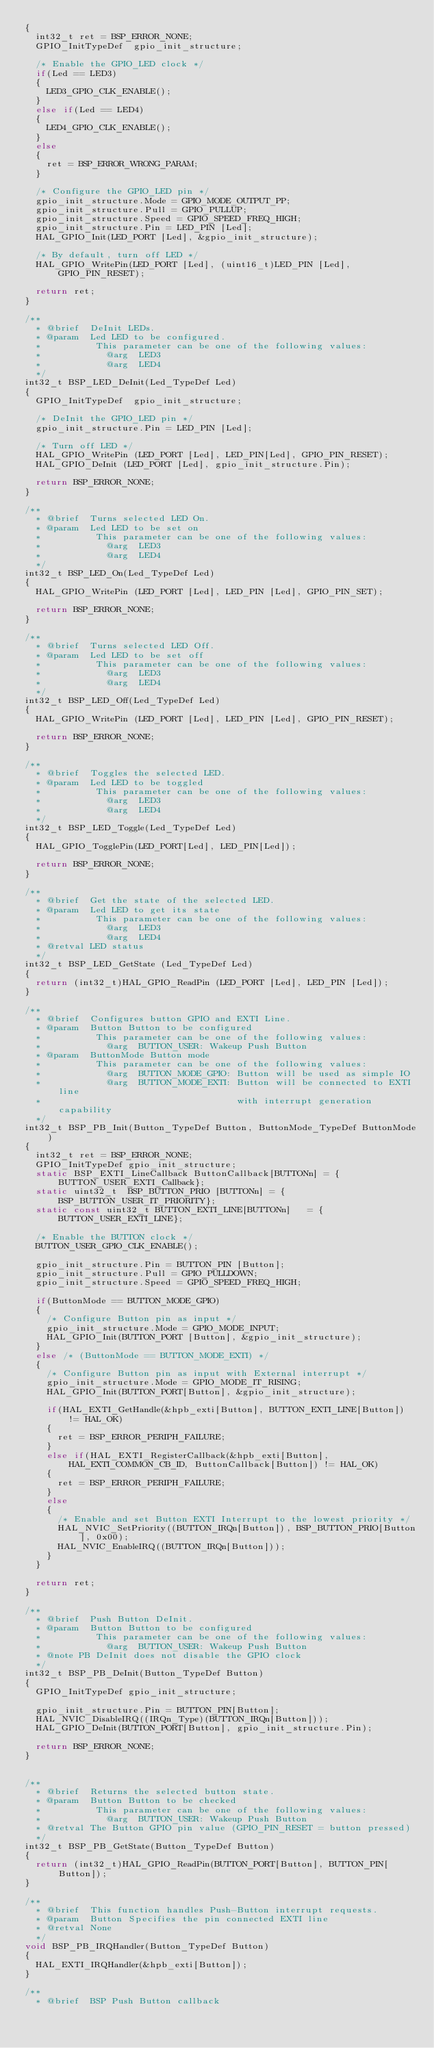Convert code to text. <code><loc_0><loc_0><loc_500><loc_500><_C_>{
  int32_t ret = BSP_ERROR_NONE;
  GPIO_InitTypeDef  gpio_init_structure;

  /* Enable the GPIO_LED clock */
  if(Led == LED3)
  {
    LED3_GPIO_CLK_ENABLE();
  }
  else if(Led == LED4)
  {
    LED4_GPIO_CLK_ENABLE();
  }
  else
  {
    ret = BSP_ERROR_WRONG_PARAM;
  }

  /* Configure the GPIO_LED pin */
  gpio_init_structure.Mode = GPIO_MODE_OUTPUT_PP;
  gpio_init_structure.Pull = GPIO_PULLUP;
  gpio_init_structure.Speed = GPIO_SPEED_FREQ_HIGH;
  gpio_init_structure.Pin = LED_PIN [Led];
  HAL_GPIO_Init(LED_PORT [Led], &gpio_init_structure);

  /* By default, turn off LED */
  HAL_GPIO_WritePin(LED_PORT [Led], (uint16_t)LED_PIN [Led], GPIO_PIN_RESET);

  return ret;
}

/**
  * @brief  DeInit LEDs.
  * @param  Led LED to be configured.
  *          This parameter can be one of the following values:
  *            @arg  LED3
  *            @arg  LED4
  */
int32_t BSP_LED_DeInit(Led_TypeDef Led)
{
  GPIO_InitTypeDef  gpio_init_structure;

  /* DeInit the GPIO_LED pin */
  gpio_init_structure.Pin = LED_PIN [Led];

  /* Turn off LED */
  HAL_GPIO_WritePin (LED_PORT [Led], LED_PIN[Led], GPIO_PIN_RESET);
  HAL_GPIO_DeInit (LED_PORT [Led], gpio_init_structure.Pin);

  return BSP_ERROR_NONE;
}

/**
  * @brief  Turns selected LED On.
  * @param  Led LED to be set on
  *          This parameter can be one of the following values:
  *            @arg  LED3
  *            @arg  LED4
  */
int32_t BSP_LED_On(Led_TypeDef Led)
{
  HAL_GPIO_WritePin (LED_PORT [Led], LED_PIN [Led], GPIO_PIN_SET);

  return BSP_ERROR_NONE;
}

/**
  * @brief  Turns selected LED Off.
  * @param  Led LED to be set off
  *          This parameter can be one of the following values:
  *            @arg  LED3
  *            @arg  LED4
  */
int32_t BSP_LED_Off(Led_TypeDef Led)
{
  HAL_GPIO_WritePin (LED_PORT [Led], LED_PIN [Led], GPIO_PIN_RESET);

  return BSP_ERROR_NONE;
}

/**
  * @brief  Toggles the selected LED.
  * @param  Led LED to be toggled
  *          This parameter can be one of the following values:
  *            @arg  LED3
  *            @arg  LED4
  */
int32_t BSP_LED_Toggle(Led_TypeDef Led)
{
  HAL_GPIO_TogglePin(LED_PORT[Led], LED_PIN[Led]);

  return BSP_ERROR_NONE;
}

/**
  * @brief  Get the state of the selected LED.
  * @param  Led LED to get its state
  *          This parameter can be one of the following values:
  *            @arg  LED3
  *            @arg  LED4
  * @retval LED status
  */
int32_t BSP_LED_GetState (Led_TypeDef Led)
{
  return (int32_t)HAL_GPIO_ReadPin (LED_PORT [Led], LED_PIN [Led]);
}

/**
  * @brief  Configures button GPIO and EXTI Line.
  * @param  Button Button to be configured
  *          This parameter can be one of the following values:
  *            @arg  BUTTON_USER: Wakeup Push Button
  * @param  ButtonMode Button mode
  *          This parameter can be one of the following values:
  *            @arg  BUTTON_MODE_GPIO: Button will be used as simple IO
  *            @arg  BUTTON_MODE_EXTI: Button will be connected to EXTI line
  *                                    with interrupt generation capability
  */
int32_t BSP_PB_Init(Button_TypeDef Button, ButtonMode_TypeDef ButtonMode)
{
  int32_t ret = BSP_ERROR_NONE;
  GPIO_InitTypeDef gpio_init_structure;
  static BSP_EXTI_LineCallback ButtonCallback[BUTTONn] = {BUTTON_USER_EXTI_Callback};
  static uint32_t  BSP_BUTTON_PRIO [BUTTONn] = {BSP_BUTTON_USER_IT_PRIORITY};
  static const uint32_t BUTTON_EXTI_LINE[BUTTONn]   = {BUTTON_USER_EXTI_LINE};

  /* Enable the BUTTON clock */
  BUTTON_USER_GPIO_CLK_ENABLE();

  gpio_init_structure.Pin = BUTTON_PIN [Button];
  gpio_init_structure.Pull = GPIO_PULLDOWN;
  gpio_init_structure.Speed = GPIO_SPEED_FREQ_HIGH;

  if(ButtonMode == BUTTON_MODE_GPIO)
  {
    /* Configure Button pin as input */
    gpio_init_structure.Mode = GPIO_MODE_INPUT;
    HAL_GPIO_Init(BUTTON_PORT [Button], &gpio_init_structure);
  }
  else /* (ButtonMode == BUTTON_MODE_EXTI) */
  {
    /* Configure Button pin as input with External interrupt */
    gpio_init_structure.Mode = GPIO_MODE_IT_RISING;
    HAL_GPIO_Init(BUTTON_PORT[Button], &gpio_init_structure);

    if(HAL_EXTI_GetHandle(&hpb_exti[Button], BUTTON_EXTI_LINE[Button]) != HAL_OK)
    {
      ret = BSP_ERROR_PERIPH_FAILURE;
    }
    else if(HAL_EXTI_RegisterCallback(&hpb_exti[Button],  HAL_EXTI_COMMON_CB_ID, ButtonCallback[Button]) != HAL_OK)
    {
      ret = BSP_ERROR_PERIPH_FAILURE;
    }
    else
    {
      /* Enable and set Button EXTI Interrupt to the lowest priority */
      HAL_NVIC_SetPriority((BUTTON_IRQn[Button]), BSP_BUTTON_PRIO[Button], 0x00);
      HAL_NVIC_EnableIRQ((BUTTON_IRQn[Button]));
    }
  }

  return ret;
}

/**
  * @brief  Push Button DeInit.
  * @param  Button Button to be configured
  *          This parameter can be one of the following values:
  *            @arg  BUTTON_USER: Wakeup Push Button
  * @note PB DeInit does not disable the GPIO clock
  */
int32_t BSP_PB_DeInit(Button_TypeDef Button)
{
  GPIO_InitTypeDef gpio_init_structure;

  gpio_init_structure.Pin = BUTTON_PIN[Button];
  HAL_NVIC_DisableIRQ((IRQn_Type)(BUTTON_IRQn[Button]));
  HAL_GPIO_DeInit(BUTTON_PORT[Button], gpio_init_structure.Pin);

  return BSP_ERROR_NONE;
}


/**
  * @brief  Returns the selected button state.
  * @param  Button Button to be checked
  *          This parameter can be one of the following values:
  *            @arg  BUTTON_USER: Wakeup Push Button
  * @retval The Button GPIO pin value (GPIO_PIN_RESET = button pressed)
  */
int32_t BSP_PB_GetState(Button_TypeDef Button)
{
  return (int32_t)HAL_GPIO_ReadPin(BUTTON_PORT[Button], BUTTON_PIN[Button]);
}

/**
  * @brief  This function handles Push-Button interrupt requests.
  * @param  Button Specifies the pin connected EXTI line
  * @retval None
  */
void BSP_PB_IRQHandler(Button_TypeDef Button)
{
  HAL_EXTI_IRQHandler(&hpb_exti[Button]);
}

/**
  * @brief  BSP Push Button callback</code> 